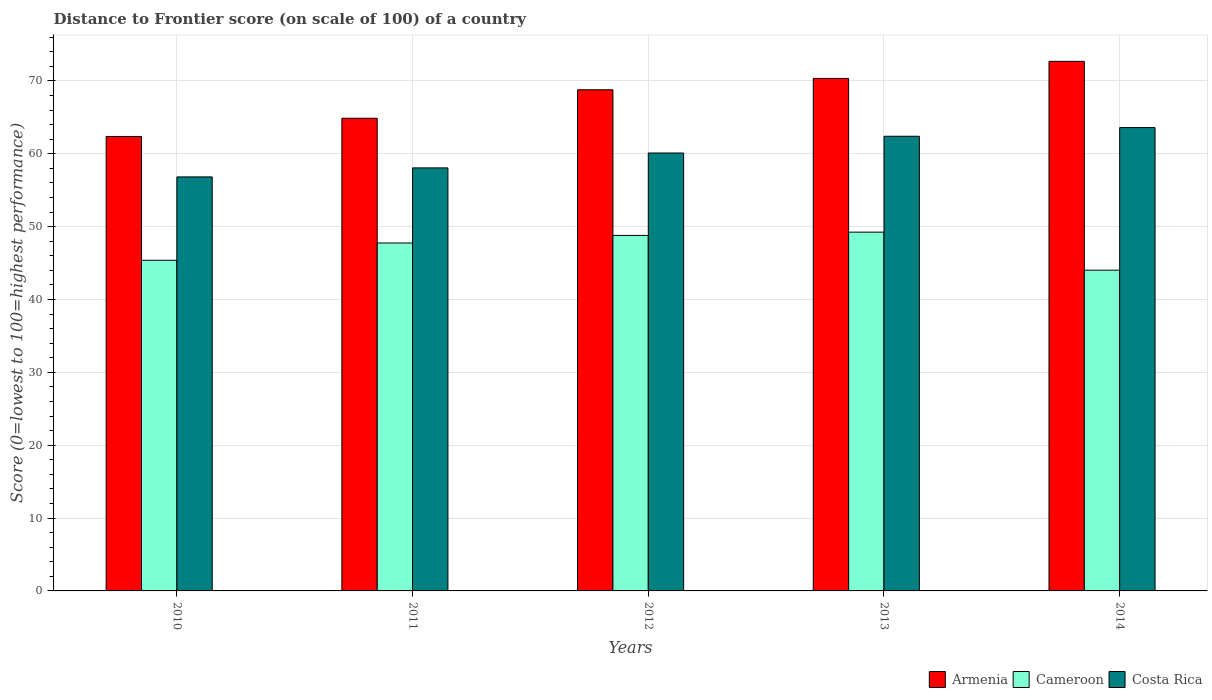How many groups of bars are there?
Provide a short and direct response. 5. How many bars are there on the 1st tick from the left?
Keep it short and to the point. 3. In how many cases, is the number of bars for a given year not equal to the number of legend labels?
Your answer should be very brief. 0. What is the distance to frontier score of in Costa Rica in 2014?
Your answer should be compact. 63.59. Across all years, what is the maximum distance to frontier score of in Armenia?
Your response must be concise. 72.68. Across all years, what is the minimum distance to frontier score of in Costa Rica?
Offer a very short reply. 56.82. What is the total distance to frontier score of in Cameroon in the graph?
Offer a terse response. 235.18. What is the difference between the distance to frontier score of in Cameroon in 2010 and that in 2012?
Provide a short and direct response. -3.41. What is the difference between the distance to frontier score of in Armenia in 2010 and the distance to frontier score of in Costa Rica in 2014?
Your answer should be very brief. -1.22. What is the average distance to frontier score of in Armenia per year?
Provide a short and direct response. 67.81. In the year 2013, what is the difference between the distance to frontier score of in Cameroon and distance to frontier score of in Armenia?
Keep it short and to the point. -21.1. In how many years, is the distance to frontier score of in Costa Rica greater than 6?
Make the answer very short. 5. What is the ratio of the distance to frontier score of in Cameroon in 2011 to that in 2014?
Make the answer very short. 1.08. Is the distance to frontier score of in Costa Rica in 2012 less than that in 2014?
Your answer should be compact. Yes. Is the difference between the distance to frontier score of in Cameroon in 2012 and 2013 greater than the difference between the distance to frontier score of in Armenia in 2012 and 2013?
Give a very brief answer. Yes. What is the difference between the highest and the second highest distance to frontier score of in Costa Rica?
Make the answer very short. 1.19. What is the difference between the highest and the lowest distance to frontier score of in Cameroon?
Your answer should be very brief. 5.22. What does the 1st bar from the left in 2010 represents?
Offer a terse response. Armenia. What does the 3rd bar from the right in 2010 represents?
Offer a very short reply. Armenia. How many bars are there?
Your response must be concise. 15. How many years are there in the graph?
Keep it short and to the point. 5. Are the values on the major ticks of Y-axis written in scientific E-notation?
Your answer should be very brief. No. Does the graph contain grids?
Offer a very short reply. Yes. What is the title of the graph?
Keep it short and to the point. Distance to Frontier score (on scale of 100) of a country. Does "High income" appear as one of the legend labels in the graph?
Make the answer very short. No. What is the label or title of the X-axis?
Provide a succinct answer. Years. What is the label or title of the Y-axis?
Make the answer very short. Score (0=lowest to 100=highest performance). What is the Score (0=lowest to 100=highest performance) of Armenia in 2010?
Your response must be concise. 62.37. What is the Score (0=lowest to 100=highest performance) in Cameroon in 2010?
Give a very brief answer. 45.38. What is the Score (0=lowest to 100=highest performance) of Costa Rica in 2010?
Keep it short and to the point. 56.82. What is the Score (0=lowest to 100=highest performance) of Armenia in 2011?
Give a very brief answer. 64.87. What is the Score (0=lowest to 100=highest performance) of Cameroon in 2011?
Provide a short and direct response. 47.75. What is the Score (0=lowest to 100=highest performance) of Costa Rica in 2011?
Offer a very short reply. 58.06. What is the Score (0=lowest to 100=highest performance) of Armenia in 2012?
Provide a succinct answer. 68.78. What is the Score (0=lowest to 100=highest performance) of Cameroon in 2012?
Provide a short and direct response. 48.79. What is the Score (0=lowest to 100=highest performance) of Costa Rica in 2012?
Provide a short and direct response. 60.1. What is the Score (0=lowest to 100=highest performance) in Armenia in 2013?
Make the answer very short. 70.34. What is the Score (0=lowest to 100=highest performance) of Cameroon in 2013?
Ensure brevity in your answer.  49.24. What is the Score (0=lowest to 100=highest performance) in Costa Rica in 2013?
Give a very brief answer. 62.4. What is the Score (0=lowest to 100=highest performance) of Armenia in 2014?
Your response must be concise. 72.68. What is the Score (0=lowest to 100=highest performance) of Cameroon in 2014?
Make the answer very short. 44.02. What is the Score (0=lowest to 100=highest performance) of Costa Rica in 2014?
Offer a terse response. 63.59. Across all years, what is the maximum Score (0=lowest to 100=highest performance) of Armenia?
Offer a very short reply. 72.68. Across all years, what is the maximum Score (0=lowest to 100=highest performance) of Cameroon?
Give a very brief answer. 49.24. Across all years, what is the maximum Score (0=lowest to 100=highest performance) of Costa Rica?
Offer a very short reply. 63.59. Across all years, what is the minimum Score (0=lowest to 100=highest performance) of Armenia?
Your answer should be very brief. 62.37. Across all years, what is the minimum Score (0=lowest to 100=highest performance) in Cameroon?
Your answer should be very brief. 44.02. Across all years, what is the minimum Score (0=lowest to 100=highest performance) in Costa Rica?
Offer a terse response. 56.82. What is the total Score (0=lowest to 100=highest performance) in Armenia in the graph?
Your response must be concise. 339.04. What is the total Score (0=lowest to 100=highest performance) of Cameroon in the graph?
Your response must be concise. 235.18. What is the total Score (0=lowest to 100=highest performance) in Costa Rica in the graph?
Your response must be concise. 300.97. What is the difference between the Score (0=lowest to 100=highest performance) in Armenia in 2010 and that in 2011?
Your answer should be compact. -2.5. What is the difference between the Score (0=lowest to 100=highest performance) in Cameroon in 2010 and that in 2011?
Make the answer very short. -2.37. What is the difference between the Score (0=lowest to 100=highest performance) of Costa Rica in 2010 and that in 2011?
Offer a very short reply. -1.24. What is the difference between the Score (0=lowest to 100=highest performance) of Armenia in 2010 and that in 2012?
Your response must be concise. -6.41. What is the difference between the Score (0=lowest to 100=highest performance) of Cameroon in 2010 and that in 2012?
Your response must be concise. -3.41. What is the difference between the Score (0=lowest to 100=highest performance) of Costa Rica in 2010 and that in 2012?
Provide a succinct answer. -3.28. What is the difference between the Score (0=lowest to 100=highest performance) of Armenia in 2010 and that in 2013?
Keep it short and to the point. -7.97. What is the difference between the Score (0=lowest to 100=highest performance) in Cameroon in 2010 and that in 2013?
Provide a short and direct response. -3.86. What is the difference between the Score (0=lowest to 100=highest performance) in Costa Rica in 2010 and that in 2013?
Keep it short and to the point. -5.58. What is the difference between the Score (0=lowest to 100=highest performance) in Armenia in 2010 and that in 2014?
Offer a terse response. -10.31. What is the difference between the Score (0=lowest to 100=highest performance) of Cameroon in 2010 and that in 2014?
Give a very brief answer. 1.36. What is the difference between the Score (0=lowest to 100=highest performance) in Costa Rica in 2010 and that in 2014?
Provide a short and direct response. -6.77. What is the difference between the Score (0=lowest to 100=highest performance) in Armenia in 2011 and that in 2012?
Offer a terse response. -3.91. What is the difference between the Score (0=lowest to 100=highest performance) in Cameroon in 2011 and that in 2012?
Make the answer very short. -1.04. What is the difference between the Score (0=lowest to 100=highest performance) of Costa Rica in 2011 and that in 2012?
Ensure brevity in your answer.  -2.04. What is the difference between the Score (0=lowest to 100=highest performance) of Armenia in 2011 and that in 2013?
Your response must be concise. -5.47. What is the difference between the Score (0=lowest to 100=highest performance) in Cameroon in 2011 and that in 2013?
Make the answer very short. -1.49. What is the difference between the Score (0=lowest to 100=highest performance) in Costa Rica in 2011 and that in 2013?
Offer a terse response. -4.34. What is the difference between the Score (0=lowest to 100=highest performance) of Armenia in 2011 and that in 2014?
Provide a short and direct response. -7.81. What is the difference between the Score (0=lowest to 100=highest performance) of Cameroon in 2011 and that in 2014?
Provide a short and direct response. 3.73. What is the difference between the Score (0=lowest to 100=highest performance) of Costa Rica in 2011 and that in 2014?
Your answer should be compact. -5.53. What is the difference between the Score (0=lowest to 100=highest performance) of Armenia in 2012 and that in 2013?
Keep it short and to the point. -1.56. What is the difference between the Score (0=lowest to 100=highest performance) of Cameroon in 2012 and that in 2013?
Make the answer very short. -0.45. What is the difference between the Score (0=lowest to 100=highest performance) in Costa Rica in 2012 and that in 2013?
Offer a very short reply. -2.3. What is the difference between the Score (0=lowest to 100=highest performance) in Armenia in 2012 and that in 2014?
Provide a succinct answer. -3.9. What is the difference between the Score (0=lowest to 100=highest performance) in Cameroon in 2012 and that in 2014?
Provide a succinct answer. 4.77. What is the difference between the Score (0=lowest to 100=highest performance) in Costa Rica in 2012 and that in 2014?
Your response must be concise. -3.49. What is the difference between the Score (0=lowest to 100=highest performance) of Armenia in 2013 and that in 2014?
Your answer should be very brief. -2.34. What is the difference between the Score (0=lowest to 100=highest performance) of Cameroon in 2013 and that in 2014?
Your response must be concise. 5.22. What is the difference between the Score (0=lowest to 100=highest performance) in Costa Rica in 2013 and that in 2014?
Provide a succinct answer. -1.19. What is the difference between the Score (0=lowest to 100=highest performance) in Armenia in 2010 and the Score (0=lowest to 100=highest performance) in Cameroon in 2011?
Your answer should be compact. 14.62. What is the difference between the Score (0=lowest to 100=highest performance) of Armenia in 2010 and the Score (0=lowest to 100=highest performance) of Costa Rica in 2011?
Make the answer very short. 4.31. What is the difference between the Score (0=lowest to 100=highest performance) of Cameroon in 2010 and the Score (0=lowest to 100=highest performance) of Costa Rica in 2011?
Provide a succinct answer. -12.68. What is the difference between the Score (0=lowest to 100=highest performance) in Armenia in 2010 and the Score (0=lowest to 100=highest performance) in Cameroon in 2012?
Provide a succinct answer. 13.58. What is the difference between the Score (0=lowest to 100=highest performance) in Armenia in 2010 and the Score (0=lowest to 100=highest performance) in Costa Rica in 2012?
Give a very brief answer. 2.27. What is the difference between the Score (0=lowest to 100=highest performance) of Cameroon in 2010 and the Score (0=lowest to 100=highest performance) of Costa Rica in 2012?
Offer a terse response. -14.72. What is the difference between the Score (0=lowest to 100=highest performance) in Armenia in 2010 and the Score (0=lowest to 100=highest performance) in Cameroon in 2013?
Provide a short and direct response. 13.13. What is the difference between the Score (0=lowest to 100=highest performance) of Armenia in 2010 and the Score (0=lowest to 100=highest performance) of Costa Rica in 2013?
Your answer should be very brief. -0.03. What is the difference between the Score (0=lowest to 100=highest performance) of Cameroon in 2010 and the Score (0=lowest to 100=highest performance) of Costa Rica in 2013?
Offer a terse response. -17.02. What is the difference between the Score (0=lowest to 100=highest performance) in Armenia in 2010 and the Score (0=lowest to 100=highest performance) in Cameroon in 2014?
Offer a terse response. 18.35. What is the difference between the Score (0=lowest to 100=highest performance) of Armenia in 2010 and the Score (0=lowest to 100=highest performance) of Costa Rica in 2014?
Your answer should be very brief. -1.22. What is the difference between the Score (0=lowest to 100=highest performance) in Cameroon in 2010 and the Score (0=lowest to 100=highest performance) in Costa Rica in 2014?
Provide a short and direct response. -18.21. What is the difference between the Score (0=lowest to 100=highest performance) of Armenia in 2011 and the Score (0=lowest to 100=highest performance) of Cameroon in 2012?
Ensure brevity in your answer.  16.08. What is the difference between the Score (0=lowest to 100=highest performance) of Armenia in 2011 and the Score (0=lowest to 100=highest performance) of Costa Rica in 2012?
Provide a short and direct response. 4.77. What is the difference between the Score (0=lowest to 100=highest performance) in Cameroon in 2011 and the Score (0=lowest to 100=highest performance) in Costa Rica in 2012?
Keep it short and to the point. -12.35. What is the difference between the Score (0=lowest to 100=highest performance) in Armenia in 2011 and the Score (0=lowest to 100=highest performance) in Cameroon in 2013?
Ensure brevity in your answer.  15.63. What is the difference between the Score (0=lowest to 100=highest performance) in Armenia in 2011 and the Score (0=lowest to 100=highest performance) in Costa Rica in 2013?
Provide a succinct answer. 2.47. What is the difference between the Score (0=lowest to 100=highest performance) of Cameroon in 2011 and the Score (0=lowest to 100=highest performance) of Costa Rica in 2013?
Offer a terse response. -14.65. What is the difference between the Score (0=lowest to 100=highest performance) in Armenia in 2011 and the Score (0=lowest to 100=highest performance) in Cameroon in 2014?
Provide a succinct answer. 20.85. What is the difference between the Score (0=lowest to 100=highest performance) of Armenia in 2011 and the Score (0=lowest to 100=highest performance) of Costa Rica in 2014?
Offer a terse response. 1.28. What is the difference between the Score (0=lowest to 100=highest performance) of Cameroon in 2011 and the Score (0=lowest to 100=highest performance) of Costa Rica in 2014?
Your answer should be very brief. -15.84. What is the difference between the Score (0=lowest to 100=highest performance) of Armenia in 2012 and the Score (0=lowest to 100=highest performance) of Cameroon in 2013?
Provide a succinct answer. 19.54. What is the difference between the Score (0=lowest to 100=highest performance) of Armenia in 2012 and the Score (0=lowest to 100=highest performance) of Costa Rica in 2013?
Your answer should be compact. 6.38. What is the difference between the Score (0=lowest to 100=highest performance) of Cameroon in 2012 and the Score (0=lowest to 100=highest performance) of Costa Rica in 2013?
Your answer should be very brief. -13.61. What is the difference between the Score (0=lowest to 100=highest performance) of Armenia in 2012 and the Score (0=lowest to 100=highest performance) of Cameroon in 2014?
Make the answer very short. 24.76. What is the difference between the Score (0=lowest to 100=highest performance) of Armenia in 2012 and the Score (0=lowest to 100=highest performance) of Costa Rica in 2014?
Your answer should be compact. 5.19. What is the difference between the Score (0=lowest to 100=highest performance) in Cameroon in 2012 and the Score (0=lowest to 100=highest performance) in Costa Rica in 2014?
Give a very brief answer. -14.8. What is the difference between the Score (0=lowest to 100=highest performance) in Armenia in 2013 and the Score (0=lowest to 100=highest performance) in Cameroon in 2014?
Your answer should be compact. 26.32. What is the difference between the Score (0=lowest to 100=highest performance) in Armenia in 2013 and the Score (0=lowest to 100=highest performance) in Costa Rica in 2014?
Keep it short and to the point. 6.75. What is the difference between the Score (0=lowest to 100=highest performance) of Cameroon in 2013 and the Score (0=lowest to 100=highest performance) of Costa Rica in 2014?
Provide a short and direct response. -14.35. What is the average Score (0=lowest to 100=highest performance) of Armenia per year?
Ensure brevity in your answer.  67.81. What is the average Score (0=lowest to 100=highest performance) in Cameroon per year?
Offer a very short reply. 47.04. What is the average Score (0=lowest to 100=highest performance) of Costa Rica per year?
Your response must be concise. 60.19. In the year 2010, what is the difference between the Score (0=lowest to 100=highest performance) of Armenia and Score (0=lowest to 100=highest performance) of Cameroon?
Keep it short and to the point. 16.99. In the year 2010, what is the difference between the Score (0=lowest to 100=highest performance) in Armenia and Score (0=lowest to 100=highest performance) in Costa Rica?
Provide a short and direct response. 5.55. In the year 2010, what is the difference between the Score (0=lowest to 100=highest performance) of Cameroon and Score (0=lowest to 100=highest performance) of Costa Rica?
Your answer should be very brief. -11.44. In the year 2011, what is the difference between the Score (0=lowest to 100=highest performance) in Armenia and Score (0=lowest to 100=highest performance) in Cameroon?
Your answer should be compact. 17.12. In the year 2011, what is the difference between the Score (0=lowest to 100=highest performance) of Armenia and Score (0=lowest to 100=highest performance) of Costa Rica?
Keep it short and to the point. 6.81. In the year 2011, what is the difference between the Score (0=lowest to 100=highest performance) of Cameroon and Score (0=lowest to 100=highest performance) of Costa Rica?
Give a very brief answer. -10.31. In the year 2012, what is the difference between the Score (0=lowest to 100=highest performance) of Armenia and Score (0=lowest to 100=highest performance) of Cameroon?
Your response must be concise. 19.99. In the year 2012, what is the difference between the Score (0=lowest to 100=highest performance) of Armenia and Score (0=lowest to 100=highest performance) of Costa Rica?
Your response must be concise. 8.68. In the year 2012, what is the difference between the Score (0=lowest to 100=highest performance) of Cameroon and Score (0=lowest to 100=highest performance) of Costa Rica?
Give a very brief answer. -11.31. In the year 2013, what is the difference between the Score (0=lowest to 100=highest performance) of Armenia and Score (0=lowest to 100=highest performance) of Cameroon?
Your answer should be very brief. 21.1. In the year 2013, what is the difference between the Score (0=lowest to 100=highest performance) of Armenia and Score (0=lowest to 100=highest performance) of Costa Rica?
Your response must be concise. 7.94. In the year 2013, what is the difference between the Score (0=lowest to 100=highest performance) in Cameroon and Score (0=lowest to 100=highest performance) in Costa Rica?
Give a very brief answer. -13.16. In the year 2014, what is the difference between the Score (0=lowest to 100=highest performance) in Armenia and Score (0=lowest to 100=highest performance) in Cameroon?
Provide a short and direct response. 28.66. In the year 2014, what is the difference between the Score (0=lowest to 100=highest performance) in Armenia and Score (0=lowest to 100=highest performance) in Costa Rica?
Make the answer very short. 9.09. In the year 2014, what is the difference between the Score (0=lowest to 100=highest performance) in Cameroon and Score (0=lowest to 100=highest performance) in Costa Rica?
Your response must be concise. -19.57. What is the ratio of the Score (0=lowest to 100=highest performance) of Armenia in 2010 to that in 2011?
Your answer should be very brief. 0.96. What is the ratio of the Score (0=lowest to 100=highest performance) of Cameroon in 2010 to that in 2011?
Your answer should be compact. 0.95. What is the ratio of the Score (0=lowest to 100=highest performance) of Costa Rica in 2010 to that in 2011?
Provide a succinct answer. 0.98. What is the ratio of the Score (0=lowest to 100=highest performance) in Armenia in 2010 to that in 2012?
Your answer should be compact. 0.91. What is the ratio of the Score (0=lowest to 100=highest performance) in Cameroon in 2010 to that in 2012?
Provide a short and direct response. 0.93. What is the ratio of the Score (0=lowest to 100=highest performance) of Costa Rica in 2010 to that in 2012?
Provide a succinct answer. 0.95. What is the ratio of the Score (0=lowest to 100=highest performance) in Armenia in 2010 to that in 2013?
Ensure brevity in your answer.  0.89. What is the ratio of the Score (0=lowest to 100=highest performance) in Cameroon in 2010 to that in 2013?
Offer a terse response. 0.92. What is the ratio of the Score (0=lowest to 100=highest performance) of Costa Rica in 2010 to that in 2013?
Provide a short and direct response. 0.91. What is the ratio of the Score (0=lowest to 100=highest performance) in Armenia in 2010 to that in 2014?
Your answer should be very brief. 0.86. What is the ratio of the Score (0=lowest to 100=highest performance) in Cameroon in 2010 to that in 2014?
Provide a succinct answer. 1.03. What is the ratio of the Score (0=lowest to 100=highest performance) of Costa Rica in 2010 to that in 2014?
Provide a short and direct response. 0.89. What is the ratio of the Score (0=lowest to 100=highest performance) in Armenia in 2011 to that in 2012?
Provide a succinct answer. 0.94. What is the ratio of the Score (0=lowest to 100=highest performance) in Cameroon in 2011 to that in 2012?
Your answer should be compact. 0.98. What is the ratio of the Score (0=lowest to 100=highest performance) in Costa Rica in 2011 to that in 2012?
Provide a succinct answer. 0.97. What is the ratio of the Score (0=lowest to 100=highest performance) in Armenia in 2011 to that in 2013?
Your response must be concise. 0.92. What is the ratio of the Score (0=lowest to 100=highest performance) of Cameroon in 2011 to that in 2013?
Offer a terse response. 0.97. What is the ratio of the Score (0=lowest to 100=highest performance) in Costa Rica in 2011 to that in 2013?
Your answer should be very brief. 0.93. What is the ratio of the Score (0=lowest to 100=highest performance) in Armenia in 2011 to that in 2014?
Provide a succinct answer. 0.89. What is the ratio of the Score (0=lowest to 100=highest performance) of Cameroon in 2011 to that in 2014?
Make the answer very short. 1.08. What is the ratio of the Score (0=lowest to 100=highest performance) in Armenia in 2012 to that in 2013?
Provide a succinct answer. 0.98. What is the ratio of the Score (0=lowest to 100=highest performance) of Cameroon in 2012 to that in 2013?
Keep it short and to the point. 0.99. What is the ratio of the Score (0=lowest to 100=highest performance) of Costa Rica in 2012 to that in 2013?
Provide a short and direct response. 0.96. What is the ratio of the Score (0=lowest to 100=highest performance) in Armenia in 2012 to that in 2014?
Your response must be concise. 0.95. What is the ratio of the Score (0=lowest to 100=highest performance) of Cameroon in 2012 to that in 2014?
Your answer should be compact. 1.11. What is the ratio of the Score (0=lowest to 100=highest performance) in Costa Rica in 2012 to that in 2014?
Give a very brief answer. 0.95. What is the ratio of the Score (0=lowest to 100=highest performance) in Armenia in 2013 to that in 2014?
Give a very brief answer. 0.97. What is the ratio of the Score (0=lowest to 100=highest performance) in Cameroon in 2013 to that in 2014?
Offer a terse response. 1.12. What is the ratio of the Score (0=lowest to 100=highest performance) in Costa Rica in 2013 to that in 2014?
Make the answer very short. 0.98. What is the difference between the highest and the second highest Score (0=lowest to 100=highest performance) in Armenia?
Offer a very short reply. 2.34. What is the difference between the highest and the second highest Score (0=lowest to 100=highest performance) of Cameroon?
Provide a short and direct response. 0.45. What is the difference between the highest and the second highest Score (0=lowest to 100=highest performance) of Costa Rica?
Your answer should be very brief. 1.19. What is the difference between the highest and the lowest Score (0=lowest to 100=highest performance) of Armenia?
Offer a terse response. 10.31. What is the difference between the highest and the lowest Score (0=lowest to 100=highest performance) of Cameroon?
Offer a very short reply. 5.22. What is the difference between the highest and the lowest Score (0=lowest to 100=highest performance) of Costa Rica?
Your answer should be compact. 6.77. 